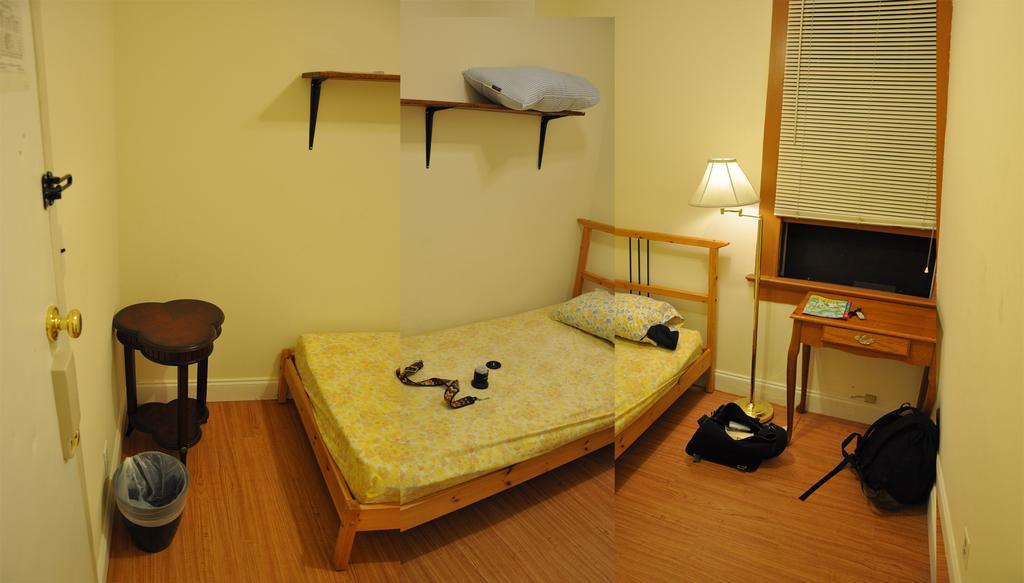Please provide a concise description of this image. This is a collage image of two images, there I can see a bed, pillow, tables, a dustbin, some stands attached to the wall and some objects on the floor. 